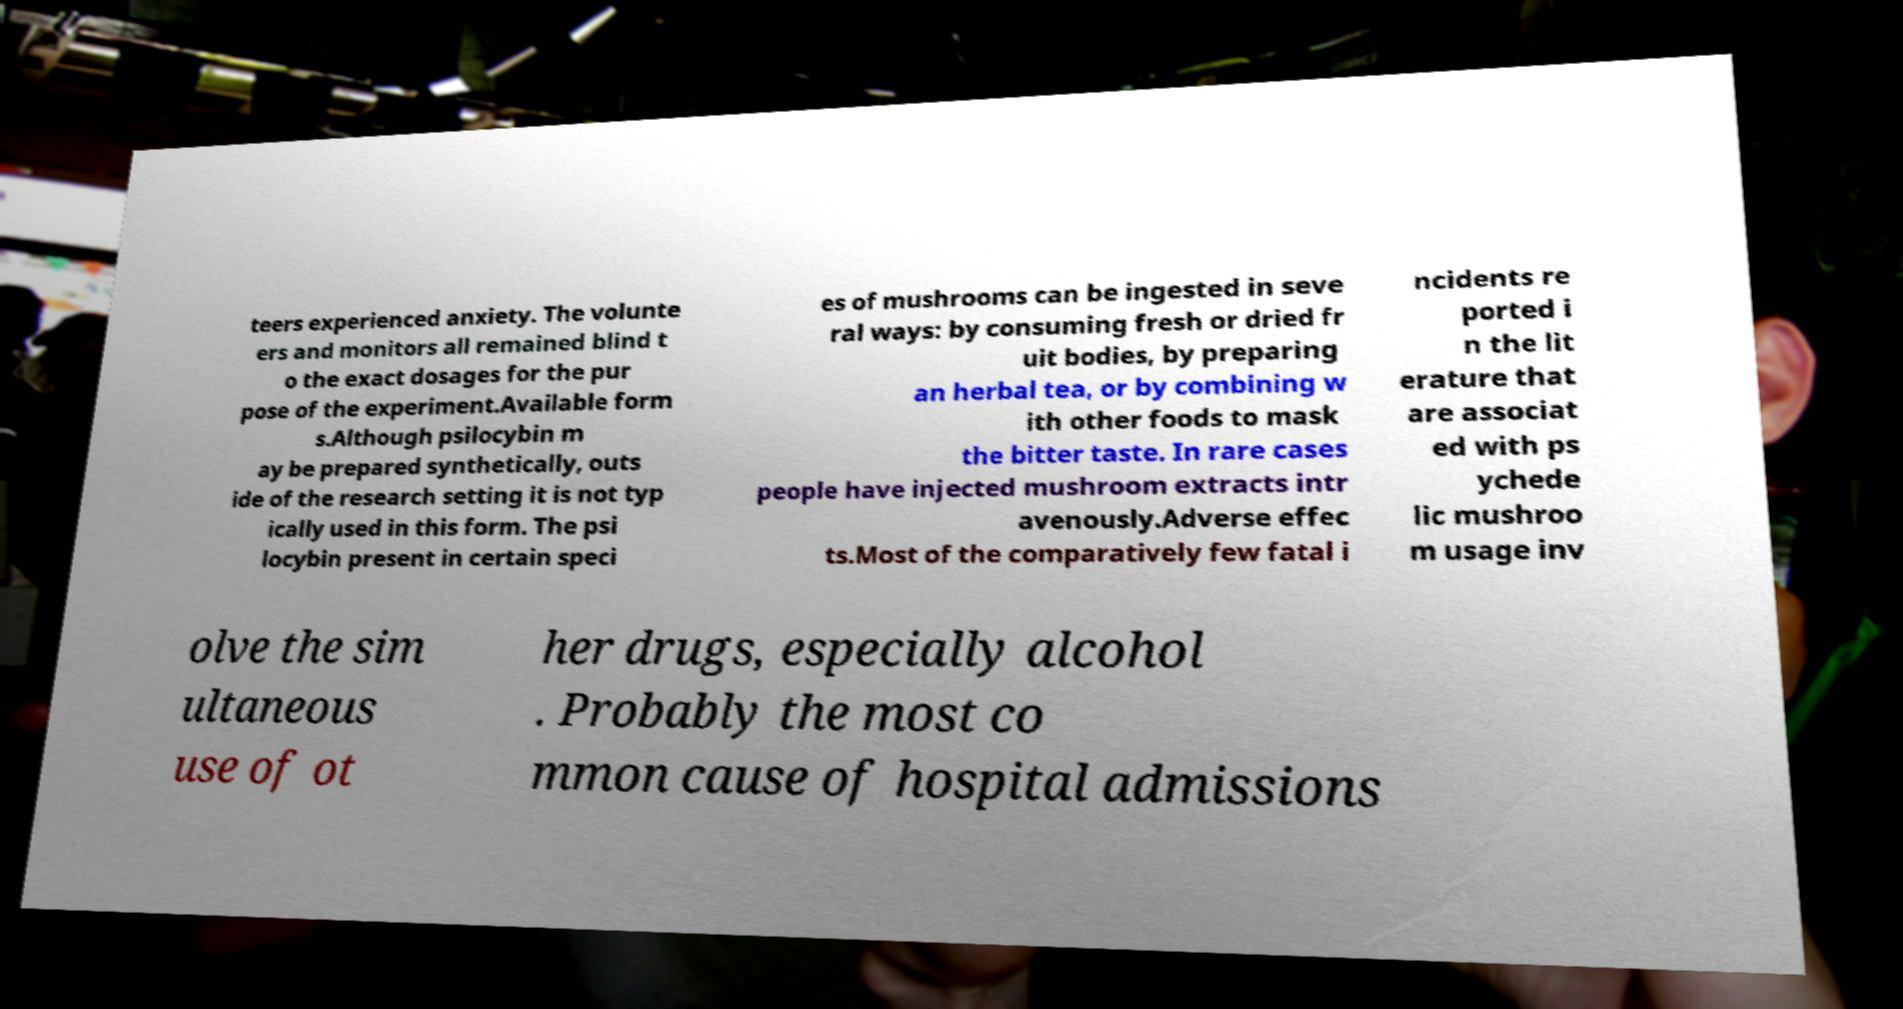Can you read and provide the text displayed in the image?This photo seems to have some interesting text. Can you extract and type it out for me? teers experienced anxiety. The volunte ers and monitors all remained blind t o the exact dosages for the pur pose of the experiment.Available form s.Although psilocybin m ay be prepared synthetically, outs ide of the research setting it is not typ ically used in this form. The psi locybin present in certain speci es of mushrooms can be ingested in seve ral ways: by consuming fresh or dried fr uit bodies, by preparing an herbal tea, or by combining w ith other foods to mask the bitter taste. In rare cases people have injected mushroom extracts intr avenously.Adverse effec ts.Most of the comparatively few fatal i ncidents re ported i n the lit erature that are associat ed with ps ychede lic mushroo m usage inv olve the sim ultaneous use of ot her drugs, especially alcohol . Probably the most co mmon cause of hospital admissions 